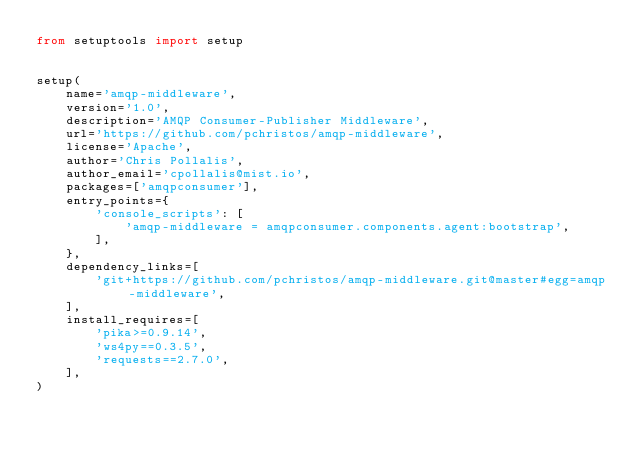Convert code to text. <code><loc_0><loc_0><loc_500><loc_500><_Python_>from setuptools import setup


setup(
    name='amqp-middleware',
    version='1.0',
    description='AMQP Consumer-Publisher Middleware',
    url='https://github.com/pchristos/amqp-middleware',
    license='Apache',
    author='Chris Pollalis',
    author_email='cpollalis@mist.io',
    packages=['amqpconsumer'],
    entry_points={
        'console_scripts': [
            'amqp-middleware = amqpconsumer.components.agent:bootstrap',
        ],
    },
    dependency_links=[
        'git+https://github.com/pchristos/amqp-middleware.git@master#egg=amqp-middleware',
    ],
    install_requires=[
        'pika>=0.9.14',
        'ws4py==0.3.5',
        'requests==2.7.0',
    ],
)
</code> 